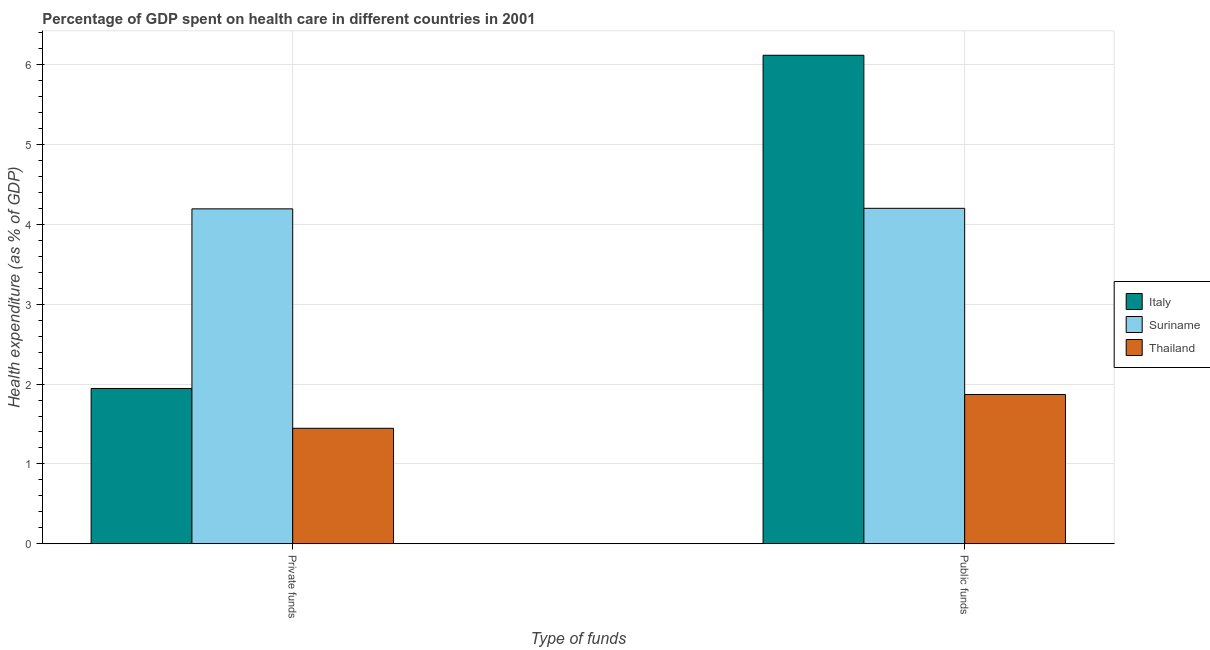How many different coloured bars are there?
Provide a succinct answer. 3. How many groups of bars are there?
Keep it short and to the point. 2. Are the number of bars per tick equal to the number of legend labels?
Your response must be concise. Yes. Are the number of bars on each tick of the X-axis equal?
Ensure brevity in your answer.  Yes. What is the label of the 1st group of bars from the left?
Provide a short and direct response. Private funds. What is the amount of public funds spent in healthcare in Italy?
Ensure brevity in your answer.  6.12. Across all countries, what is the maximum amount of private funds spent in healthcare?
Ensure brevity in your answer.  4.19. Across all countries, what is the minimum amount of public funds spent in healthcare?
Your answer should be very brief. 1.87. In which country was the amount of private funds spent in healthcare maximum?
Make the answer very short. Suriname. In which country was the amount of public funds spent in healthcare minimum?
Offer a terse response. Thailand. What is the total amount of public funds spent in healthcare in the graph?
Ensure brevity in your answer.  12.19. What is the difference between the amount of public funds spent in healthcare in Suriname and that in Italy?
Offer a very short reply. -1.92. What is the difference between the amount of public funds spent in healthcare in Suriname and the amount of private funds spent in healthcare in Thailand?
Your answer should be very brief. 2.75. What is the average amount of public funds spent in healthcare per country?
Keep it short and to the point. 4.06. What is the difference between the amount of public funds spent in healthcare and amount of private funds spent in healthcare in Suriname?
Provide a short and direct response. 0.01. In how many countries, is the amount of private funds spent in healthcare greater than 0.4 %?
Give a very brief answer. 3. What is the ratio of the amount of public funds spent in healthcare in Suriname to that in Italy?
Provide a succinct answer. 0.69. In how many countries, is the amount of private funds spent in healthcare greater than the average amount of private funds spent in healthcare taken over all countries?
Provide a short and direct response. 1. What does the 1st bar from the left in Private funds represents?
Offer a very short reply. Italy. What does the 2nd bar from the right in Public funds represents?
Provide a succinct answer. Suriname. How many countries are there in the graph?
Your response must be concise. 3. How many legend labels are there?
Make the answer very short. 3. What is the title of the graph?
Provide a succinct answer. Percentage of GDP spent on health care in different countries in 2001. Does "Azerbaijan" appear as one of the legend labels in the graph?
Ensure brevity in your answer.  No. What is the label or title of the X-axis?
Your answer should be very brief. Type of funds. What is the label or title of the Y-axis?
Offer a very short reply. Health expenditure (as % of GDP). What is the Health expenditure (as % of GDP) in Italy in Private funds?
Your answer should be very brief. 1.94. What is the Health expenditure (as % of GDP) of Suriname in Private funds?
Your answer should be compact. 4.19. What is the Health expenditure (as % of GDP) of Thailand in Private funds?
Your answer should be very brief. 1.45. What is the Health expenditure (as % of GDP) in Italy in Public funds?
Make the answer very short. 6.12. What is the Health expenditure (as % of GDP) of Suriname in Public funds?
Ensure brevity in your answer.  4.2. What is the Health expenditure (as % of GDP) of Thailand in Public funds?
Make the answer very short. 1.87. Across all Type of funds, what is the maximum Health expenditure (as % of GDP) of Italy?
Ensure brevity in your answer.  6.12. Across all Type of funds, what is the maximum Health expenditure (as % of GDP) in Suriname?
Keep it short and to the point. 4.2. Across all Type of funds, what is the maximum Health expenditure (as % of GDP) in Thailand?
Your answer should be very brief. 1.87. Across all Type of funds, what is the minimum Health expenditure (as % of GDP) in Italy?
Offer a terse response. 1.94. Across all Type of funds, what is the minimum Health expenditure (as % of GDP) of Suriname?
Keep it short and to the point. 4.19. Across all Type of funds, what is the minimum Health expenditure (as % of GDP) of Thailand?
Your response must be concise. 1.45. What is the total Health expenditure (as % of GDP) in Italy in the graph?
Your response must be concise. 8.06. What is the total Health expenditure (as % of GDP) in Suriname in the graph?
Offer a terse response. 8.39. What is the total Health expenditure (as % of GDP) in Thailand in the graph?
Your answer should be very brief. 3.32. What is the difference between the Health expenditure (as % of GDP) of Italy in Private funds and that in Public funds?
Keep it short and to the point. -4.17. What is the difference between the Health expenditure (as % of GDP) of Suriname in Private funds and that in Public funds?
Provide a short and direct response. -0.01. What is the difference between the Health expenditure (as % of GDP) in Thailand in Private funds and that in Public funds?
Your response must be concise. -0.42. What is the difference between the Health expenditure (as % of GDP) in Italy in Private funds and the Health expenditure (as % of GDP) in Suriname in Public funds?
Give a very brief answer. -2.26. What is the difference between the Health expenditure (as % of GDP) in Italy in Private funds and the Health expenditure (as % of GDP) in Thailand in Public funds?
Keep it short and to the point. 0.08. What is the difference between the Health expenditure (as % of GDP) in Suriname in Private funds and the Health expenditure (as % of GDP) in Thailand in Public funds?
Make the answer very short. 2.32. What is the average Health expenditure (as % of GDP) in Italy per Type of funds?
Ensure brevity in your answer.  4.03. What is the average Health expenditure (as % of GDP) of Suriname per Type of funds?
Give a very brief answer. 4.2. What is the average Health expenditure (as % of GDP) in Thailand per Type of funds?
Give a very brief answer. 1.66. What is the difference between the Health expenditure (as % of GDP) in Italy and Health expenditure (as % of GDP) in Suriname in Private funds?
Your response must be concise. -2.25. What is the difference between the Health expenditure (as % of GDP) of Italy and Health expenditure (as % of GDP) of Thailand in Private funds?
Offer a terse response. 0.5. What is the difference between the Health expenditure (as % of GDP) of Suriname and Health expenditure (as % of GDP) of Thailand in Private funds?
Ensure brevity in your answer.  2.75. What is the difference between the Health expenditure (as % of GDP) in Italy and Health expenditure (as % of GDP) in Suriname in Public funds?
Provide a short and direct response. 1.92. What is the difference between the Health expenditure (as % of GDP) in Italy and Health expenditure (as % of GDP) in Thailand in Public funds?
Keep it short and to the point. 4.25. What is the difference between the Health expenditure (as % of GDP) of Suriname and Health expenditure (as % of GDP) of Thailand in Public funds?
Your answer should be compact. 2.33. What is the ratio of the Health expenditure (as % of GDP) of Italy in Private funds to that in Public funds?
Provide a short and direct response. 0.32. What is the ratio of the Health expenditure (as % of GDP) in Suriname in Private funds to that in Public funds?
Offer a terse response. 1. What is the ratio of the Health expenditure (as % of GDP) of Thailand in Private funds to that in Public funds?
Your answer should be compact. 0.77. What is the difference between the highest and the second highest Health expenditure (as % of GDP) in Italy?
Your answer should be very brief. 4.17. What is the difference between the highest and the second highest Health expenditure (as % of GDP) of Suriname?
Offer a very short reply. 0.01. What is the difference between the highest and the second highest Health expenditure (as % of GDP) in Thailand?
Your answer should be compact. 0.42. What is the difference between the highest and the lowest Health expenditure (as % of GDP) in Italy?
Your response must be concise. 4.17. What is the difference between the highest and the lowest Health expenditure (as % of GDP) in Suriname?
Keep it short and to the point. 0.01. What is the difference between the highest and the lowest Health expenditure (as % of GDP) in Thailand?
Keep it short and to the point. 0.42. 